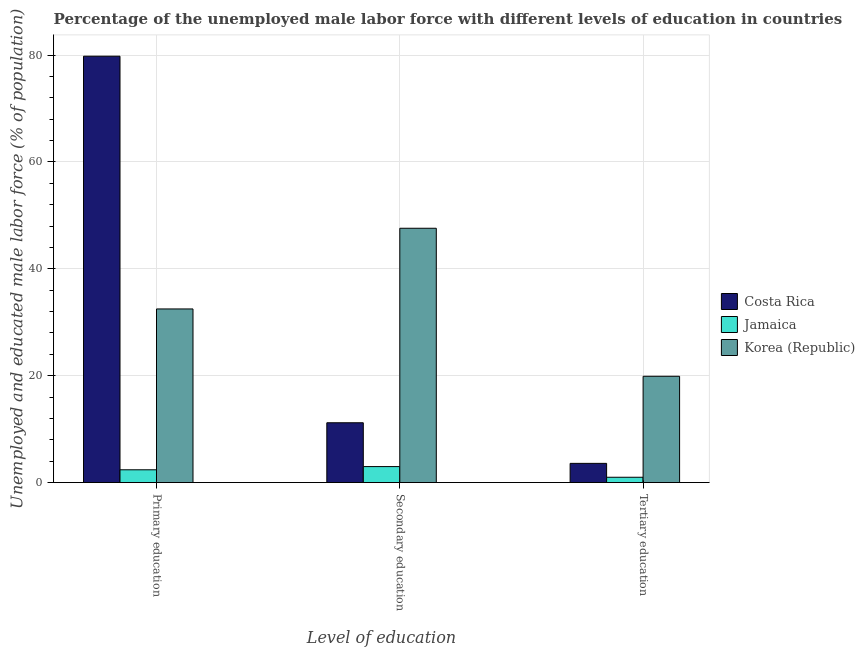How many bars are there on the 3rd tick from the left?
Your answer should be compact. 3. How many bars are there on the 3rd tick from the right?
Provide a short and direct response. 3. What is the label of the 3rd group of bars from the left?
Give a very brief answer. Tertiary education. Across all countries, what is the maximum percentage of male labor force who received tertiary education?
Keep it short and to the point. 19.9. Across all countries, what is the minimum percentage of male labor force who received tertiary education?
Ensure brevity in your answer.  1. In which country was the percentage of male labor force who received primary education maximum?
Ensure brevity in your answer.  Costa Rica. In which country was the percentage of male labor force who received secondary education minimum?
Offer a very short reply. Jamaica. What is the total percentage of male labor force who received secondary education in the graph?
Provide a succinct answer. 61.8. What is the difference between the percentage of male labor force who received secondary education in Jamaica and that in Korea (Republic)?
Provide a succinct answer. -44.6. What is the difference between the percentage of male labor force who received primary education in Costa Rica and the percentage of male labor force who received secondary education in Jamaica?
Make the answer very short. 76.8. What is the average percentage of male labor force who received primary education per country?
Your answer should be compact. 38.23. What is the difference between the percentage of male labor force who received primary education and percentage of male labor force who received secondary education in Jamaica?
Give a very brief answer. -0.6. What is the ratio of the percentage of male labor force who received secondary education in Jamaica to that in Costa Rica?
Provide a short and direct response. 0.27. Is the difference between the percentage of male labor force who received tertiary education in Costa Rica and Korea (Republic) greater than the difference between the percentage of male labor force who received secondary education in Costa Rica and Korea (Republic)?
Give a very brief answer. Yes. What is the difference between the highest and the second highest percentage of male labor force who received tertiary education?
Provide a succinct answer. 16.3. What is the difference between the highest and the lowest percentage of male labor force who received primary education?
Give a very brief answer. 77.4. In how many countries, is the percentage of male labor force who received primary education greater than the average percentage of male labor force who received primary education taken over all countries?
Make the answer very short. 1. Is the sum of the percentage of male labor force who received tertiary education in Costa Rica and Jamaica greater than the maximum percentage of male labor force who received primary education across all countries?
Keep it short and to the point. No. What does the 2nd bar from the right in Primary education represents?
Make the answer very short. Jamaica. Are the values on the major ticks of Y-axis written in scientific E-notation?
Ensure brevity in your answer.  No. Does the graph contain any zero values?
Make the answer very short. No. Does the graph contain grids?
Your response must be concise. Yes. How are the legend labels stacked?
Your answer should be compact. Vertical. What is the title of the graph?
Provide a succinct answer. Percentage of the unemployed male labor force with different levels of education in countries. Does "Swaziland" appear as one of the legend labels in the graph?
Your response must be concise. No. What is the label or title of the X-axis?
Keep it short and to the point. Level of education. What is the label or title of the Y-axis?
Give a very brief answer. Unemployed and educated male labor force (% of population). What is the Unemployed and educated male labor force (% of population) in Costa Rica in Primary education?
Your answer should be compact. 79.8. What is the Unemployed and educated male labor force (% of population) in Jamaica in Primary education?
Your answer should be very brief. 2.4. What is the Unemployed and educated male labor force (% of population) of Korea (Republic) in Primary education?
Your response must be concise. 32.5. What is the Unemployed and educated male labor force (% of population) of Costa Rica in Secondary education?
Offer a terse response. 11.2. What is the Unemployed and educated male labor force (% of population) of Jamaica in Secondary education?
Provide a succinct answer. 3. What is the Unemployed and educated male labor force (% of population) of Korea (Republic) in Secondary education?
Your answer should be very brief. 47.6. What is the Unemployed and educated male labor force (% of population) of Costa Rica in Tertiary education?
Keep it short and to the point. 3.6. What is the Unemployed and educated male labor force (% of population) of Jamaica in Tertiary education?
Make the answer very short. 1. What is the Unemployed and educated male labor force (% of population) of Korea (Republic) in Tertiary education?
Keep it short and to the point. 19.9. Across all Level of education, what is the maximum Unemployed and educated male labor force (% of population) in Costa Rica?
Your answer should be compact. 79.8. Across all Level of education, what is the maximum Unemployed and educated male labor force (% of population) in Korea (Republic)?
Provide a succinct answer. 47.6. Across all Level of education, what is the minimum Unemployed and educated male labor force (% of population) in Costa Rica?
Make the answer very short. 3.6. Across all Level of education, what is the minimum Unemployed and educated male labor force (% of population) of Jamaica?
Provide a short and direct response. 1. Across all Level of education, what is the minimum Unemployed and educated male labor force (% of population) in Korea (Republic)?
Your response must be concise. 19.9. What is the total Unemployed and educated male labor force (% of population) in Costa Rica in the graph?
Offer a very short reply. 94.6. What is the total Unemployed and educated male labor force (% of population) in Jamaica in the graph?
Your response must be concise. 6.4. What is the difference between the Unemployed and educated male labor force (% of population) of Costa Rica in Primary education and that in Secondary education?
Provide a succinct answer. 68.6. What is the difference between the Unemployed and educated male labor force (% of population) in Jamaica in Primary education and that in Secondary education?
Give a very brief answer. -0.6. What is the difference between the Unemployed and educated male labor force (% of population) of Korea (Republic) in Primary education and that in Secondary education?
Your answer should be compact. -15.1. What is the difference between the Unemployed and educated male labor force (% of population) in Costa Rica in Primary education and that in Tertiary education?
Your answer should be compact. 76.2. What is the difference between the Unemployed and educated male labor force (% of population) in Jamaica in Primary education and that in Tertiary education?
Keep it short and to the point. 1.4. What is the difference between the Unemployed and educated male labor force (% of population) of Jamaica in Secondary education and that in Tertiary education?
Your response must be concise. 2. What is the difference between the Unemployed and educated male labor force (% of population) of Korea (Republic) in Secondary education and that in Tertiary education?
Offer a very short reply. 27.7. What is the difference between the Unemployed and educated male labor force (% of population) of Costa Rica in Primary education and the Unemployed and educated male labor force (% of population) of Jamaica in Secondary education?
Your answer should be compact. 76.8. What is the difference between the Unemployed and educated male labor force (% of population) in Costa Rica in Primary education and the Unemployed and educated male labor force (% of population) in Korea (Republic) in Secondary education?
Your response must be concise. 32.2. What is the difference between the Unemployed and educated male labor force (% of population) in Jamaica in Primary education and the Unemployed and educated male labor force (% of population) in Korea (Republic) in Secondary education?
Keep it short and to the point. -45.2. What is the difference between the Unemployed and educated male labor force (% of population) in Costa Rica in Primary education and the Unemployed and educated male labor force (% of population) in Jamaica in Tertiary education?
Provide a succinct answer. 78.8. What is the difference between the Unemployed and educated male labor force (% of population) in Costa Rica in Primary education and the Unemployed and educated male labor force (% of population) in Korea (Republic) in Tertiary education?
Make the answer very short. 59.9. What is the difference between the Unemployed and educated male labor force (% of population) in Jamaica in Primary education and the Unemployed and educated male labor force (% of population) in Korea (Republic) in Tertiary education?
Your response must be concise. -17.5. What is the difference between the Unemployed and educated male labor force (% of population) in Costa Rica in Secondary education and the Unemployed and educated male labor force (% of population) in Jamaica in Tertiary education?
Provide a short and direct response. 10.2. What is the difference between the Unemployed and educated male labor force (% of population) of Jamaica in Secondary education and the Unemployed and educated male labor force (% of population) of Korea (Republic) in Tertiary education?
Make the answer very short. -16.9. What is the average Unemployed and educated male labor force (% of population) in Costa Rica per Level of education?
Offer a terse response. 31.53. What is the average Unemployed and educated male labor force (% of population) in Jamaica per Level of education?
Provide a succinct answer. 2.13. What is the average Unemployed and educated male labor force (% of population) in Korea (Republic) per Level of education?
Provide a succinct answer. 33.33. What is the difference between the Unemployed and educated male labor force (% of population) of Costa Rica and Unemployed and educated male labor force (% of population) of Jamaica in Primary education?
Provide a succinct answer. 77.4. What is the difference between the Unemployed and educated male labor force (% of population) of Costa Rica and Unemployed and educated male labor force (% of population) of Korea (Republic) in Primary education?
Ensure brevity in your answer.  47.3. What is the difference between the Unemployed and educated male labor force (% of population) in Jamaica and Unemployed and educated male labor force (% of population) in Korea (Republic) in Primary education?
Offer a very short reply. -30.1. What is the difference between the Unemployed and educated male labor force (% of population) of Costa Rica and Unemployed and educated male labor force (% of population) of Jamaica in Secondary education?
Give a very brief answer. 8.2. What is the difference between the Unemployed and educated male labor force (% of population) of Costa Rica and Unemployed and educated male labor force (% of population) of Korea (Republic) in Secondary education?
Provide a short and direct response. -36.4. What is the difference between the Unemployed and educated male labor force (% of population) in Jamaica and Unemployed and educated male labor force (% of population) in Korea (Republic) in Secondary education?
Your answer should be very brief. -44.6. What is the difference between the Unemployed and educated male labor force (% of population) in Costa Rica and Unemployed and educated male labor force (% of population) in Korea (Republic) in Tertiary education?
Make the answer very short. -16.3. What is the difference between the Unemployed and educated male labor force (% of population) of Jamaica and Unemployed and educated male labor force (% of population) of Korea (Republic) in Tertiary education?
Ensure brevity in your answer.  -18.9. What is the ratio of the Unemployed and educated male labor force (% of population) in Costa Rica in Primary education to that in Secondary education?
Your answer should be very brief. 7.12. What is the ratio of the Unemployed and educated male labor force (% of population) in Jamaica in Primary education to that in Secondary education?
Make the answer very short. 0.8. What is the ratio of the Unemployed and educated male labor force (% of population) in Korea (Republic) in Primary education to that in Secondary education?
Ensure brevity in your answer.  0.68. What is the ratio of the Unemployed and educated male labor force (% of population) of Costa Rica in Primary education to that in Tertiary education?
Your answer should be compact. 22.17. What is the ratio of the Unemployed and educated male labor force (% of population) of Jamaica in Primary education to that in Tertiary education?
Your answer should be very brief. 2.4. What is the ratio of the Unemployed and educated male labor force (% of population) in Korea (Republic) in Primary education to that in Tertiary education?
Ensure brevity in your answer.  1.63. What is the ratio of the Unemployed and educated male labor force (% of population) of Costa Rica in Secondary education to that in Tertiary education?
Offer a very short reply. 3.11. What is the ratio of the Unemployed and educated male labor force (% of population) in Jamaica in Secondary education to that in Tertiary education?
Provide a short and direct response. 3. What is the ratio of the Unemployed and educated male labor force (% of population) of Korea (Republic) in Secondary education to that in Tertiary education?
Offer a terse response. 2.39. What is the difference between the highest and the second highest Unemployed and educated male labor force (% of population) in Costa Rica?
Provide a succinct answer. 68.6. What is the difference between the highest and the second highest Unemployed and educated male labor force (% of population) in Jamaica?
Provide a succinct answer. 0.6. What is the difference between the highest and the second highest Unemployed and educated male labor force (% of population) of Korea (Republic)?
Offer a very short reply. 15.1. What is the difference between the highest and the lowest Unemployed and educated male labor force (% of population) in Costa Rica?
Keep it short and to the point. 76.2. What is the difference between the highest and the lowest Unemployed and educated male labor force (% of population) in Korea (Republic)?
Offer a terse response. 27.7. 